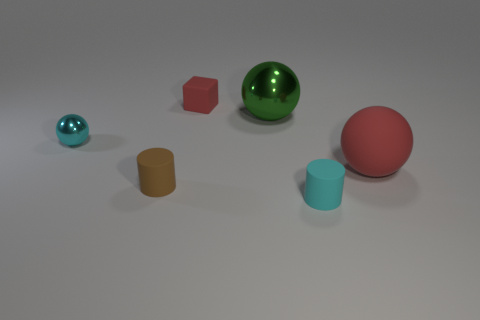There is a small cyan thing that is the same material as the large green sphere; what shape is it? sphere 